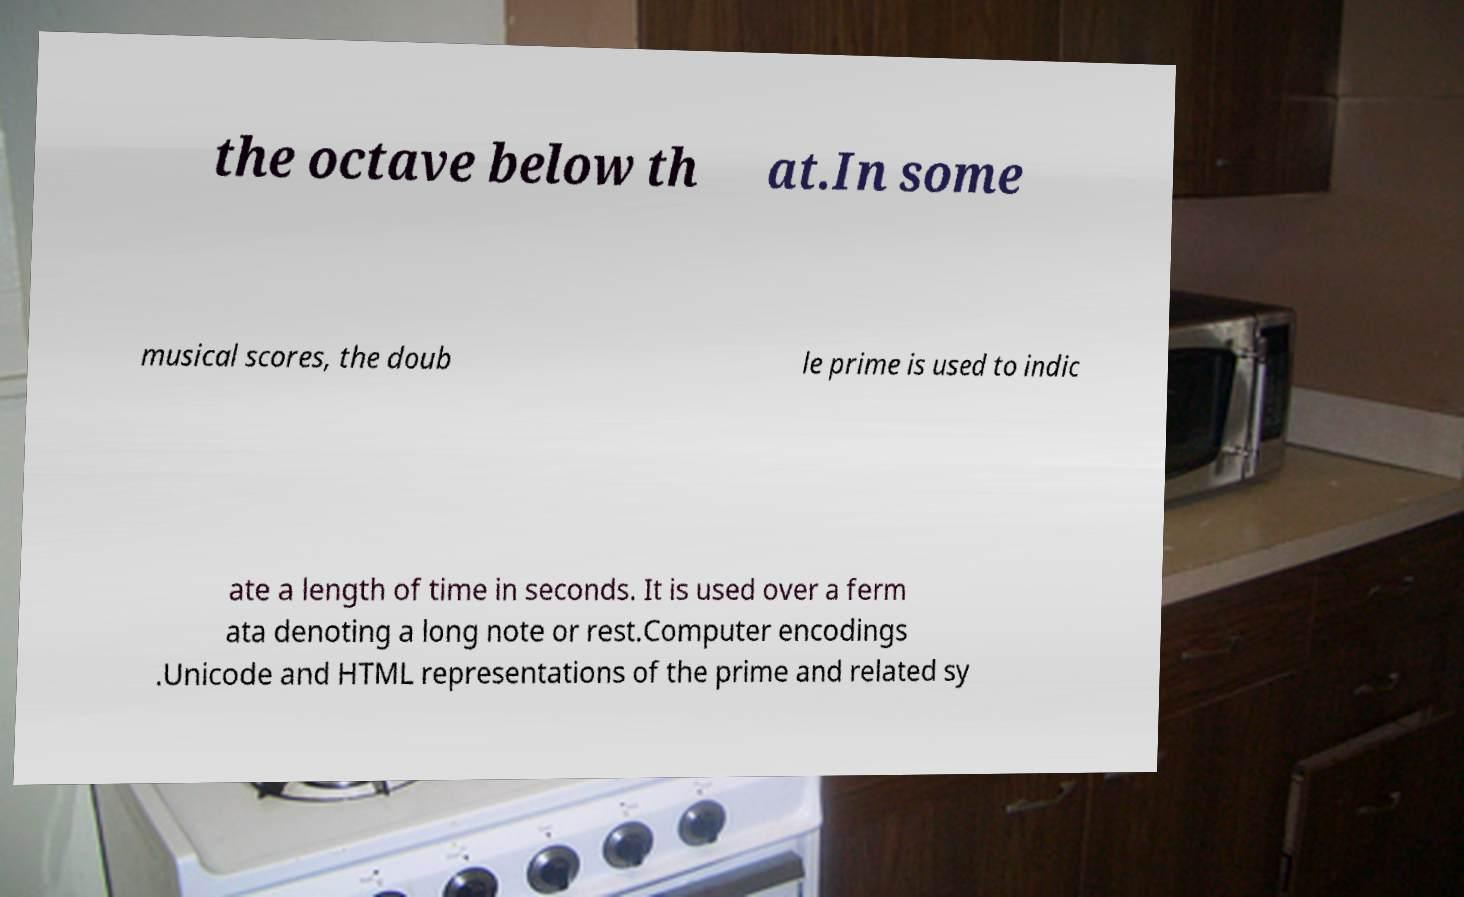Can you accurately transcribe the text from the provided image for me? the octave below th at.In some musical scores, the doub le prime is used to indic ate a length of time in seconds. It is used over a ferm ata denoting a long note or rest.Computer encodings .Unicode and HTML representations of the prime and related sy 